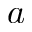Convert formula to latex. <formula><loc_0><loc_0><loc_500><loc_500>a</formula> 